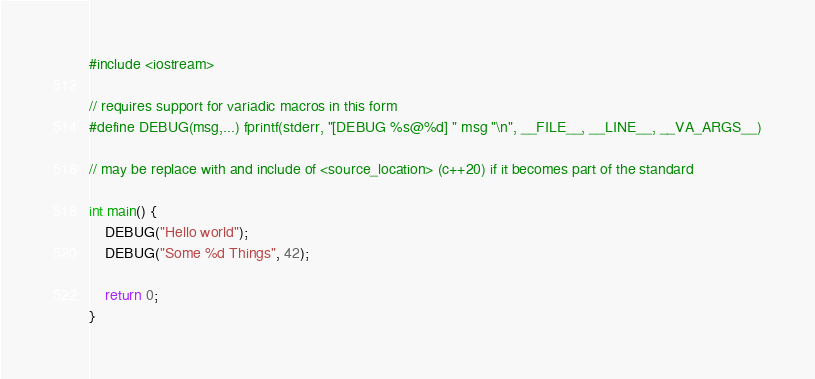Convert code to text. <code><loc_0><loc_0><loc_500><loc_500><_C++_>#include <iostream>

// requires support for variadic macros in this form
#define DEBUG(msg,...) fprintf(stderr, "[DEBUG %s@%d] " msg "\n", __FILE__, __LINE__, __VA_ARGS__)

// may be replace with and include of <source_location> (c++20) if it becomes part of the standard

int main() {
    DEBUG("Hello world");
    DEBUG("Some %d Things", 42);

    return 0;
}
</code> 